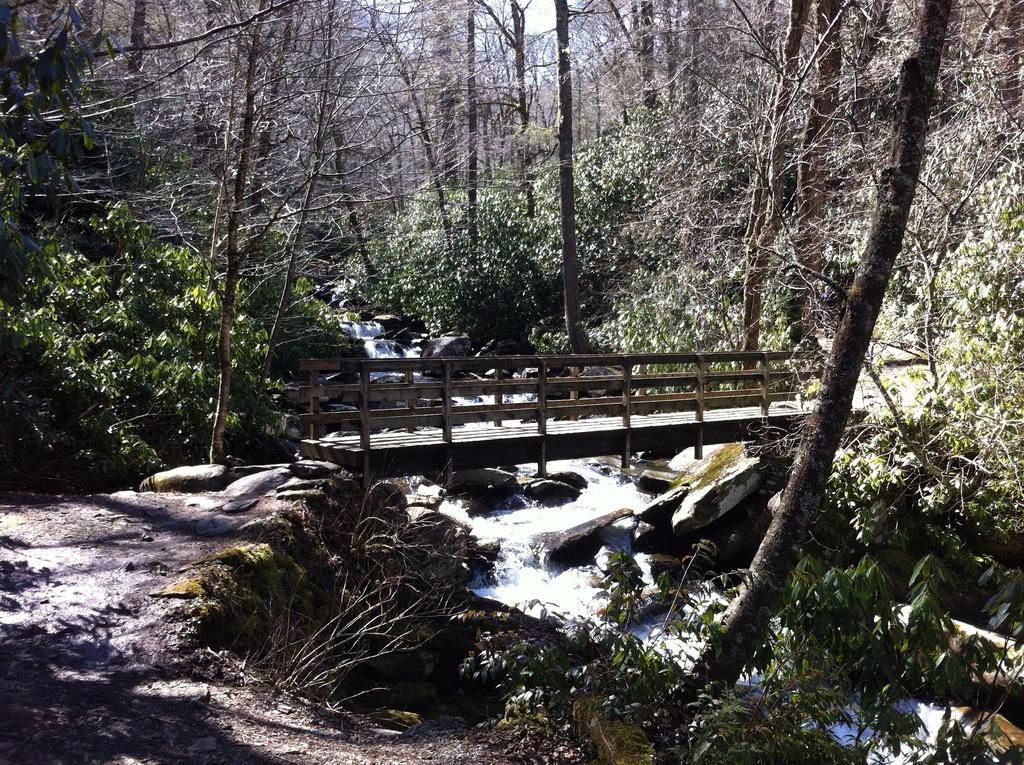Please provide a concise description of this image. In this picture I can see wooden bridge. I can see the river. I can see trees. 